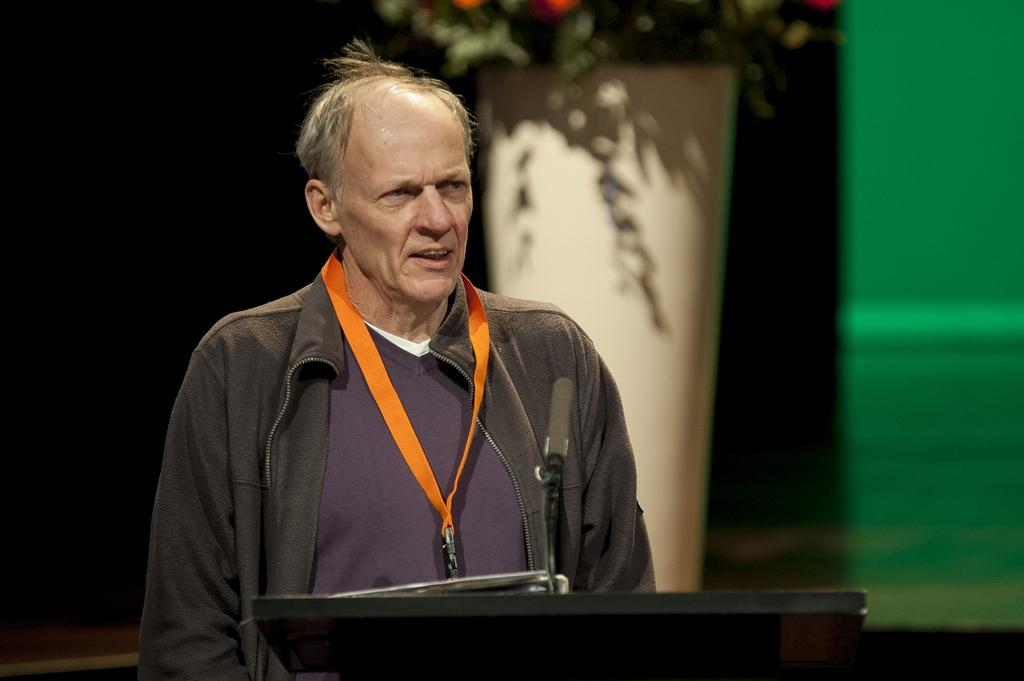Who or what is present in the image? There is a person in the image. What is the person wearing that is visible in the image? The person is wearing an ID card. What can be seen in the background of the image? There are art leaves and a wall in the background of the image. What electronic device is present at the bottom of the image? There is a monitor at the bottom of the image. What type of canvas is being used to create the art leaves in the image? There is no canvas present in the image; the art leaves are already created and visible in the background. 